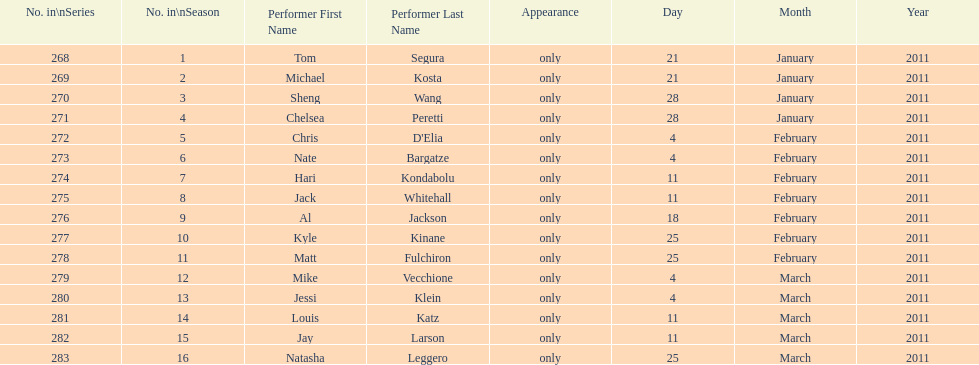Which month had the most performers? February. 